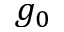<formula> <loc_0><loc_0><loc_500><loc_500>g _ { 0 }</formula> 